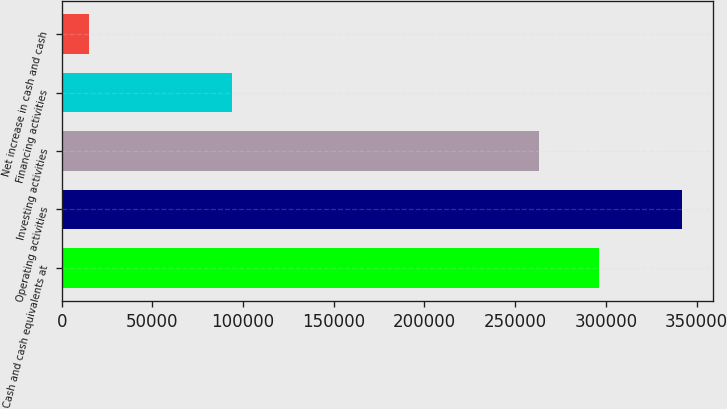Convert chart to OTSL. <chart><loc_0><loc_0><loc_500><loc_500><bar_chart><fcel>Cash and cash equivalents at<fcel>Operating activities<fcel>Investing activities<fcel>Financing activities<fcel>Net increase in cash and cash<nl><fcel>296008<fcel>341939<fcel>263335<fcel>94135<fcel>15202<nl></chart> 